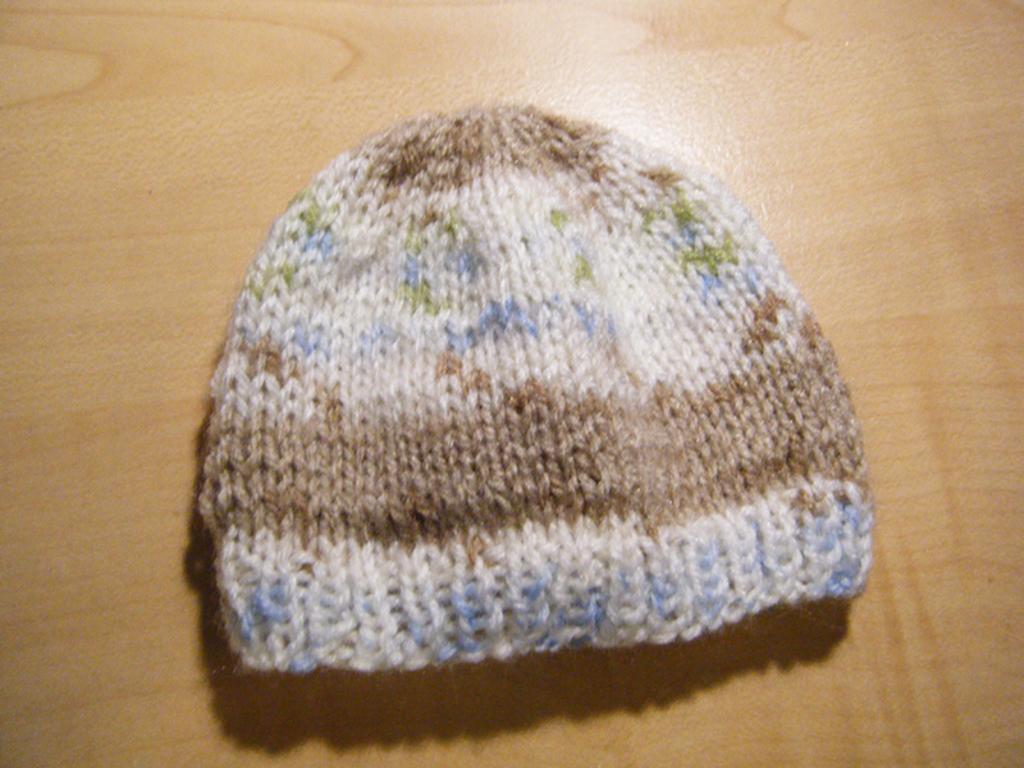Describe this image in one or two sentences. In this image there is a cap which is on the surface which is brown in colour. 